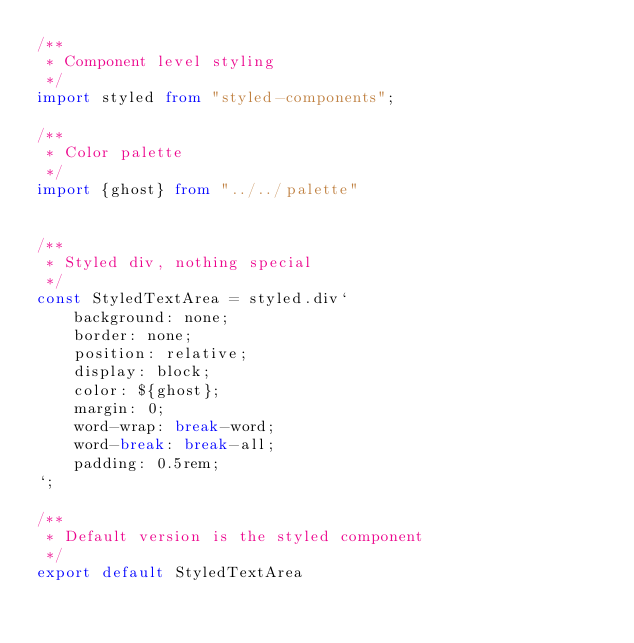Convert code to text. <code><loc_0><loc_0><loc_500><loc_500><_TypeScript_>/**
 * Component level styling
 */
import styled from "styled-components";

/**
 * Color palette
 */
import {ghost} from "../../palette"


/**
 * Styled div, nothing special
 */
const StyledTextArea = styled.div`
    background: none;
    border: none;
    position: relative;
    display: block;
    color: ${ghost};
    margin: 0;
    word-wrap: break-word;
    word-break: break-all;
    padding: 0.5rem;
`;

/**
 * Default version is the styled component
 */
export default StyledTextArea</code> 